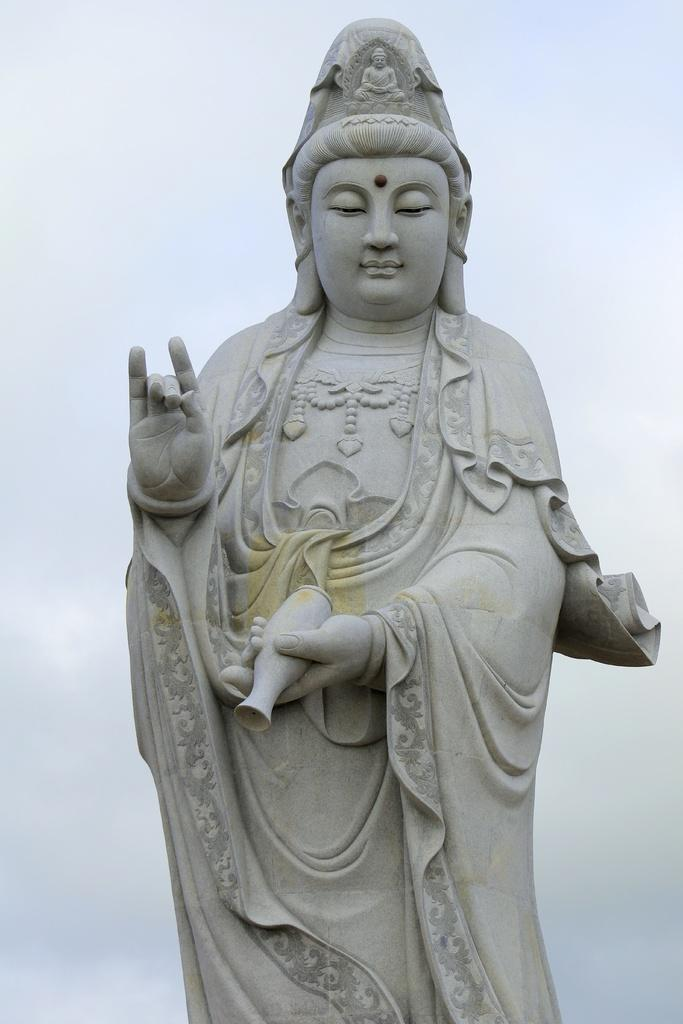What is the main subject of the image? There is a statue in the image. What material is the statue made of? The statue is made of stone. What color is the statue? The statue is grey in color. What can be seen in the background of the image? There is a sky visible in the background of the image. What type of drug is the statue holding in the image? There is no drug present in the image; the statue is made of stone and does not hold any objects. 